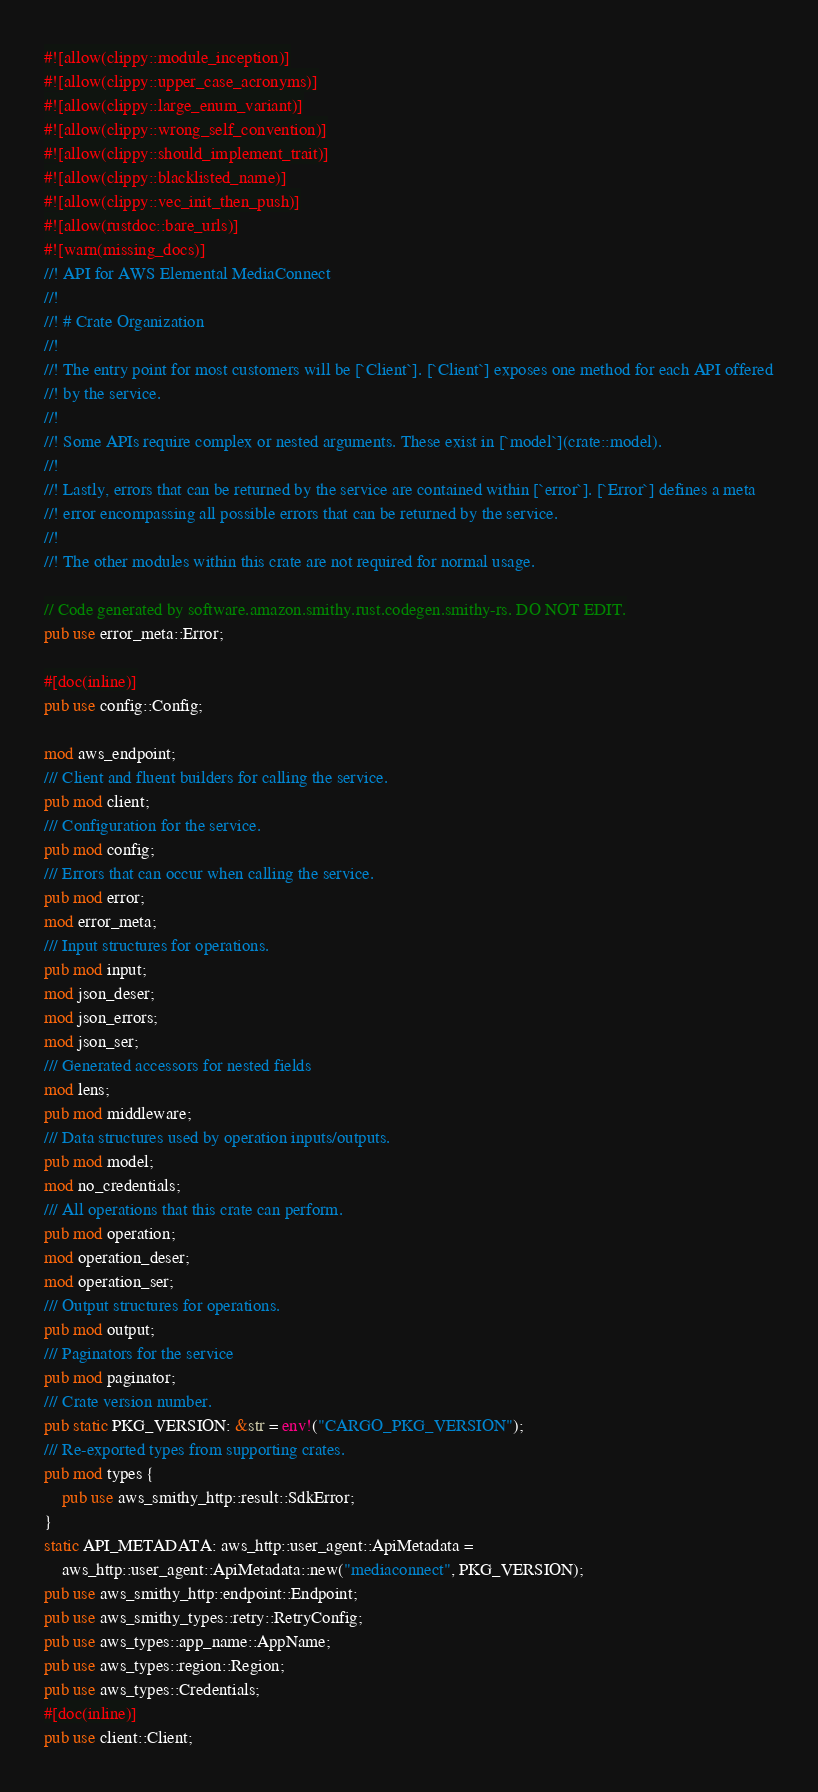<code> <loc_0><loc_0><loc_500><loc_500><_Rust_>#![allow(clippy::module_inception)]
#![allow(clippy::upper_case_acronyms)]
#![allow(clippy::large_enum_variant)]
#![allow(clippy::wrong_self_convention)]
#![allow(clippy::should_implement_trait)]
#![allow(clippy::blacklisted_name)]
#![allow(clippy::vec_init_then_push)]
#![allow(rustdoc::bare_urls)]
#![warn(missing_docs)]
//! API for AWS Elemental MediaConnect
//!
//! # Crate Organization
//!
//! The entry point for most customers will be [`Client`]. [`Client`] exposes one method for each API offered
//! by the service.
//!
//! Some APIs require complex or nested arguments. These exist in [`model`](crate::model).
//!
//! Lastly, errors that can be returned by the service are contained within [`error`]. [`Error`] defines a meta
//! error encompassing all possible errors that can be returned by the service.
//!
//! The other modules within this crate are not required for normal usage.

// Code generated by software.amazon.smithy.rust.codegen.smithy-rs. DO NOT EDIT.
pub use error_meta::Error;

#[doc(inline)]
pub use config::Config;

mod aws_endpoint;
/// Client and fluent builders for calling the service.
pub mod client;
/// Configuration for the service.
pub mod config;
/// Errors that can occur when calling the service.
pub mod error;
mod error_meta;
/// Input structures for operations.
pub mod input;
mod json_deser;
mod json_errors;
mod json_ser;
/// Generated accessors for nested fields
mod lens;
pub mod middleware;
/// Data structures used by operation inputs/outputs.
pub mod model;
mod no_credentials;
/// All operations that this crate can perform.
pub mod operation;
mod operation_deser;
mod operation_ser;
/// Output structures for operations.
pub mod output;
/// Paginators for the service
pub mod paginator;
/// Crate version number.
pub static PKG_VERSION: &str = env!("CARGO_PKG_VERSION");
/// Re-exported types from supporting crates.
pub mod types {
    pub use aws_smithy_http::result::SdkError;
}
static API_METADATA: aws_http::user_agent::ApiMetadata =
    aws_http::user_agent::ApiMetadata::new("mediaconnect", PKG_VERSION);
pub use aws_smithy_http::endpoint::Endpoint;
pub use aws_smithy_types::retry::RetryConfig;
pub use aws_types::app_name::AppName;
pub use aws_types::region::Region;
pub use aws_types::Credentials;
#[doc(inline)]
pub use client::Client;
</code> 